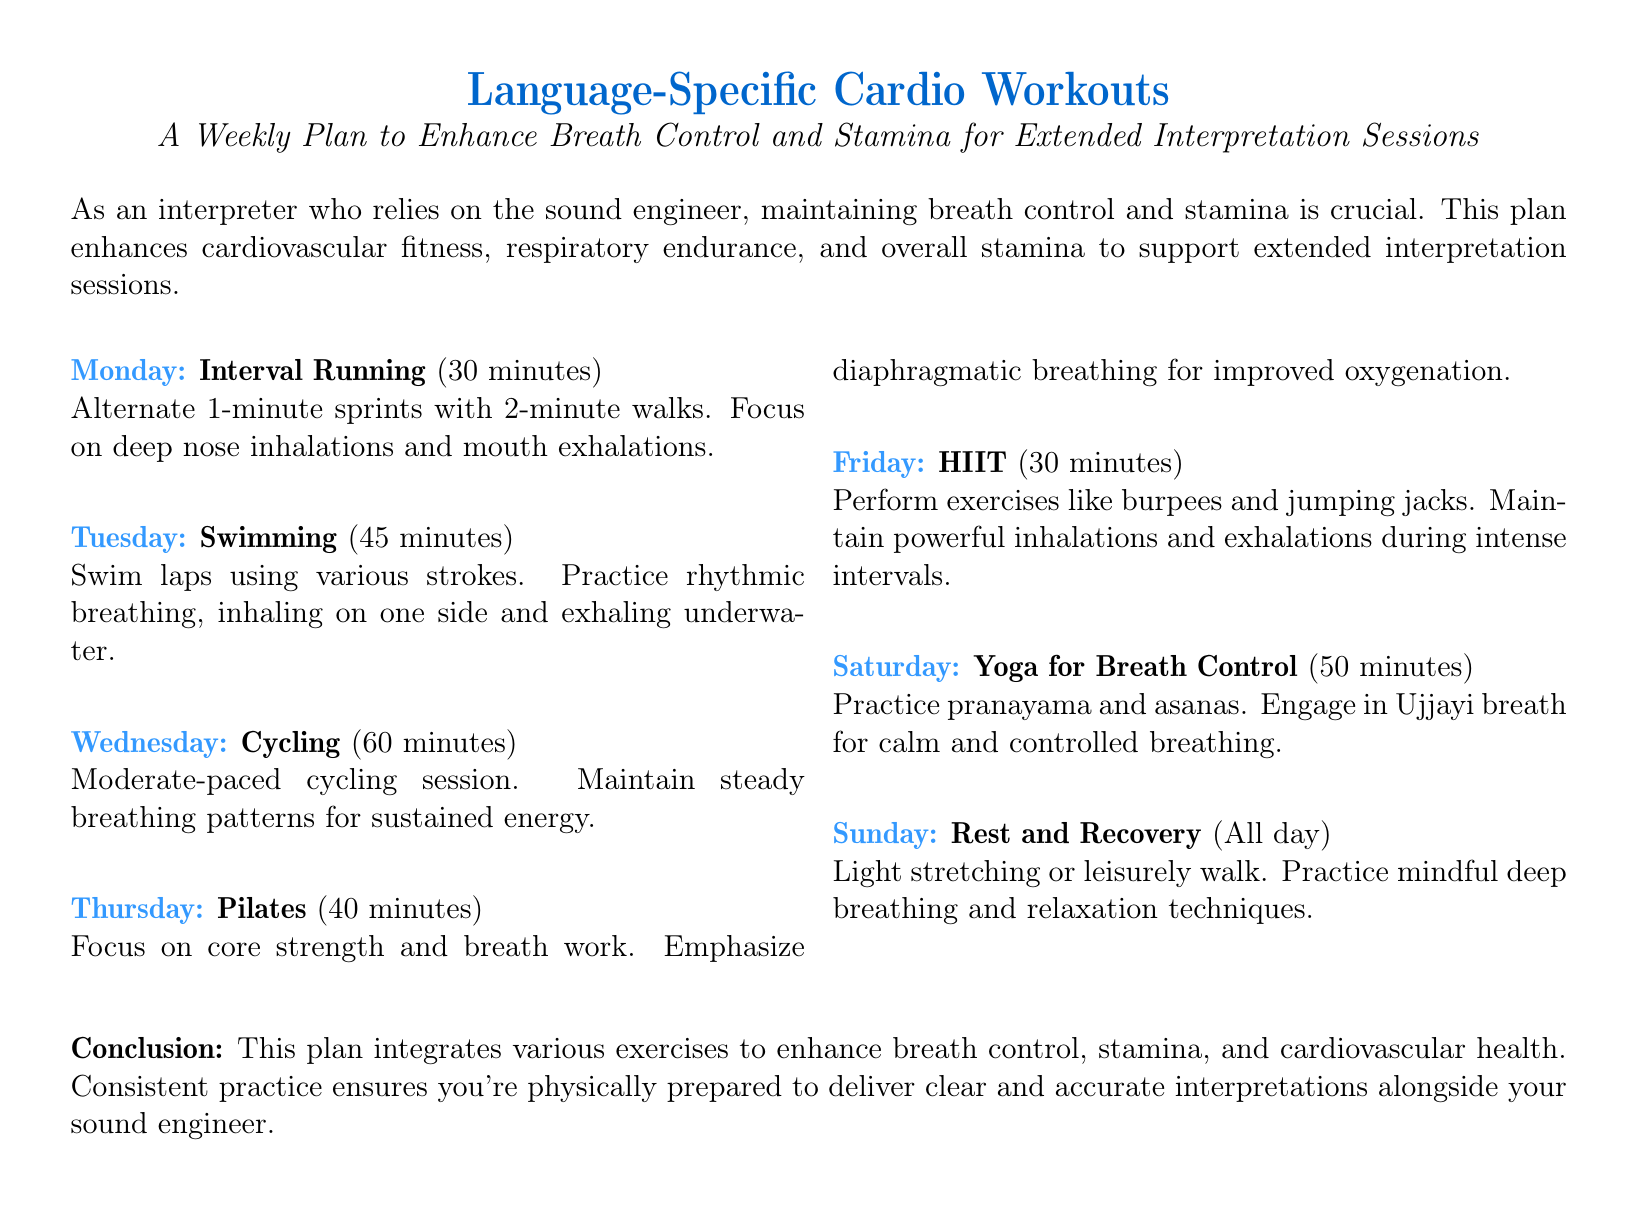What is the first workout listed for Monday? The first workout listed for Monday is "Interval Running".
Answer: Interval Running How long is the swimming session on Tuesday? The swimming session on Tuesday lasts for 45 minutes.
Answer: 45 minutes What type of breathing is emphasized during Pilates on Thursday? During Pilates on Thursday, diaphragmatic breathing is emphasized for improved oxygenation.
Answer: Diaphragmatic breathing How many minutes is the HIIT session on Friday? The HIIT session on Friday is 30 minutes long.
Answer: 30 minutes What day is designated for rest and recovery? Sunday is designated for rest and recovery in the workout plan.
Answer: Sunday Which workout incorporates Ujjayi breath? The "Yoga for Breath Control" on Saturday incorporates Ujjayi breath.
Answer: Yoga for Breath Control What is the main focus of the workout plan? The main focus of the workout plan is to enhance breath control and stamina.
Answer: Enhance breath control and stamina What type of workout is performed on Wednesday? The workout performed on Wednesday is Cycling.
Answer: Cycling 